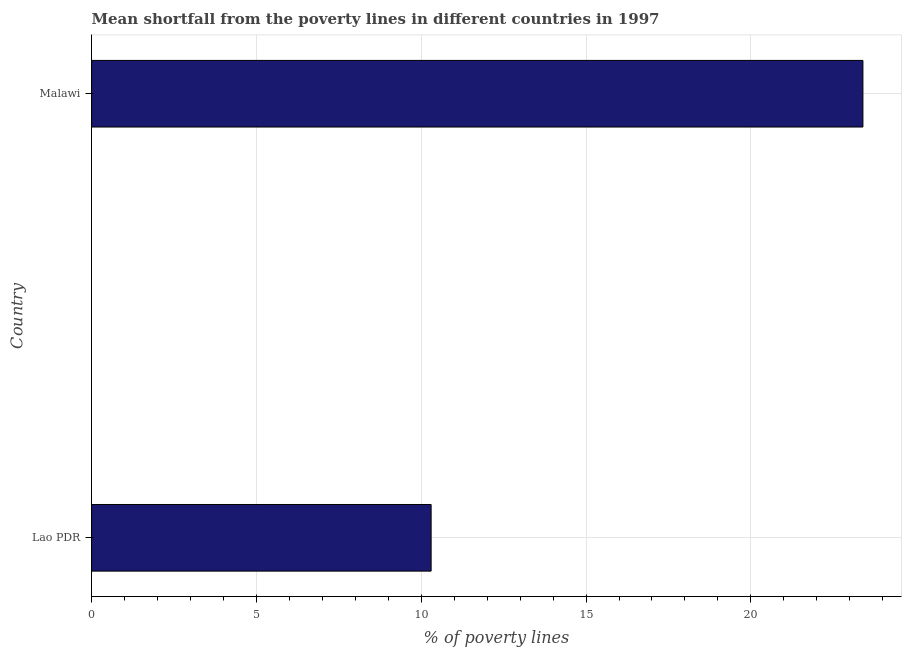What is the title of the graph?
Your answer should be very brief. Mean shortfall from the poverty lines in different countries in 1997. What is the label or title of the X-axis?
Provide a succinct answer. % of poverty lines. What is the label or title of the Y-axis?
Provide a short and direct response. Country. Across all countries, what is the maximum poverty gap at national poverty lines?
Your answer should be compact. 23.4. In which country was the poverty gap at national poverty lines maximum?
Keep it short and to the point. Malawi. In which country was the poverty gap at national poverty lines minimum?
Give a very brief answer. Lao PDR. What is the sum of the poverty gap at national poverty lines?
Keep it short and to the point. 33.7. What is the average poverty gap at national poverty lines per country?
Ensure brevity in your answer.  16.85. What is the median poverty gap at national poverty lines?
Provide a succinct answer. 16.85. What is the ratio of the poverty gap at national poverty lines in Lao PDR to that in Malawi?
Your response must be concise. 0.44. Is the poverty gap at national poverty lines in Lao PDR less than that in Malawi?
Keep it short and to the point. Yes. How many bars are there?
Your response must be concise. 2. Are all the bars in the graph horizontal?
Provide a succinct answer. Yes. What is the difference between two consecutive major ticks on the X-axis?
Ensure brevity in your answer.  5. Are the values on the major ticks of X-axis written in scientific E-notation?
Provide a short and direct response. No. What is the % of poverty lines in Malawi?
Your answer should be compact. 23.4. What is the ratio of the % of poverty lines in Lao PDR to that in Malawi?
Make the answer very short. 0.44. 